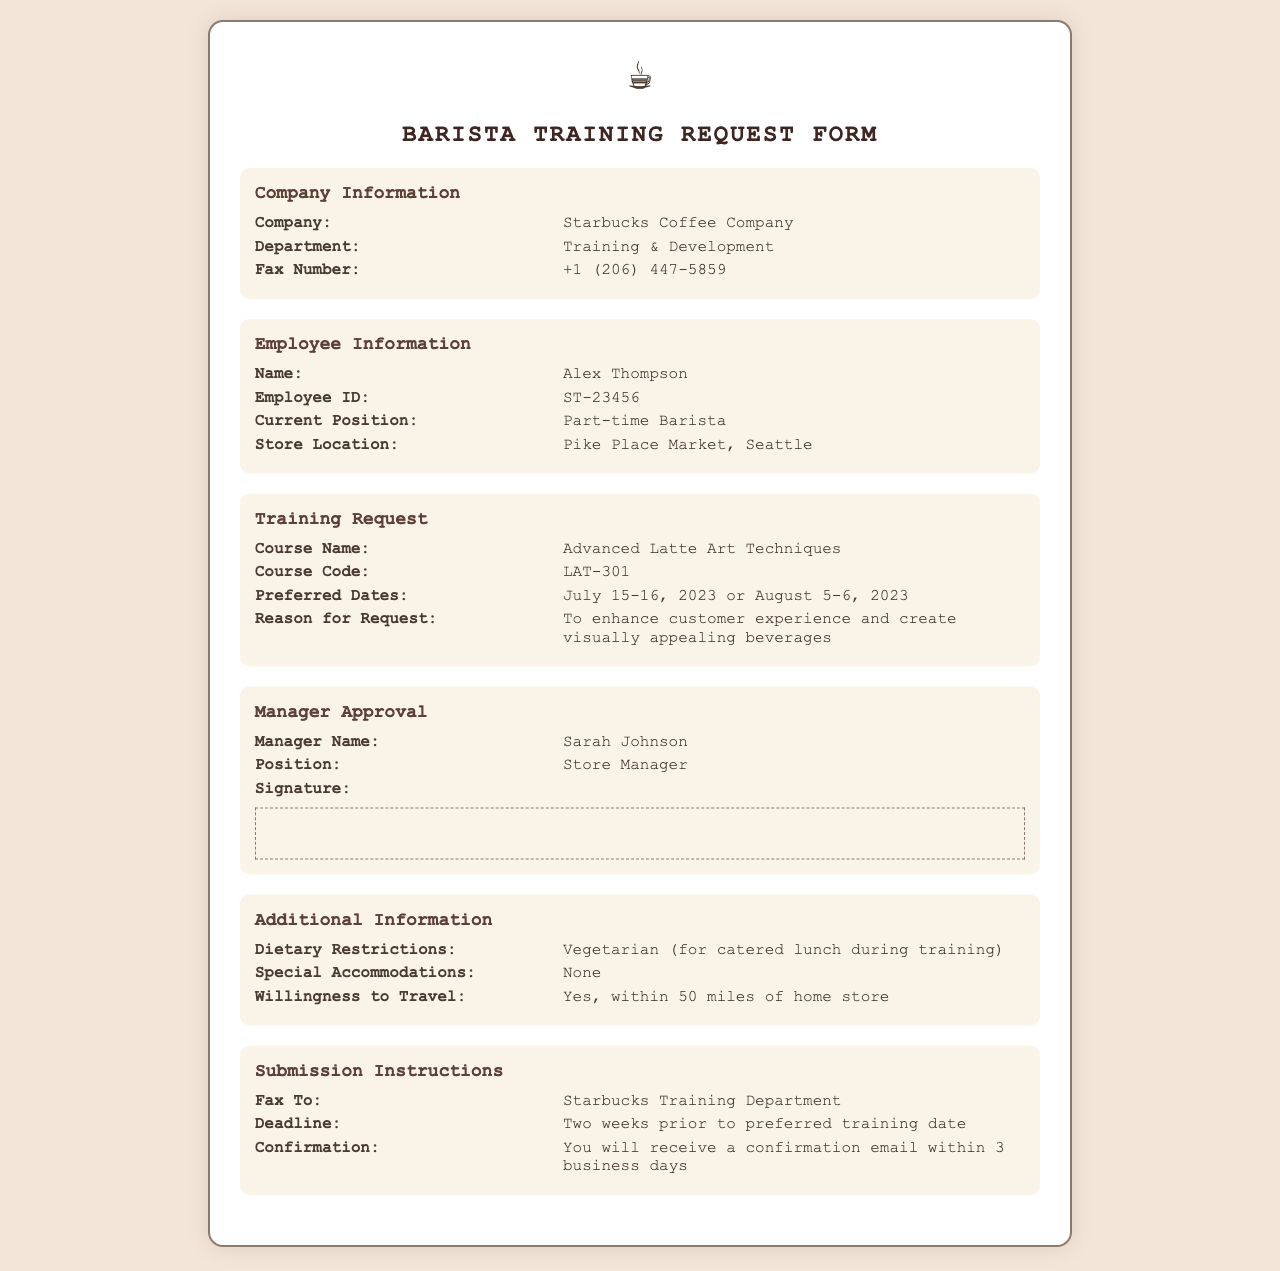What is the name of the course? The course name is specified in the training request section of the document, which is "Advanced Latte Art Techniques."
Answer: Advanced Latte Art Techniques What is the employee's current position? The employee's current position can be found in the employee information section, which states "Part-time Barista."
Answer: Part-time Barista What is the preferred training date? The preferred training dates are mentioned in the training request section, provided as "July 15-16, 2023 or August 5-6, 2023."
Answer: July 15-16, 2023 or August 5-6, 2023 What is the fax number for the company? The company's fax number is listed in the company information section as "+1 (206) 447-5859."
Answer: +1 (206) 447-5859 Who is the manager approving the training request? The manager's name can be found in the manager approval section, which states "Sarah Johnson."
Answer: Sarah Johnson What dietary restrictions does the employee have? The dietary restrictions are indicated in the additional information section, which states "Vegetarian."
Answer: Vegetarian When is the submission deadline for the request? The deadline for submission is outlined in the submission instructions, which states "Two weeks prior to preferred training date."
Answer: Two weeks prior to preferred training date What is the employee's store location? The employee's store location is mentioned in the employee information section as "Pike Place Market, Seattle."
Answer: Pike Place Market, Seattle What will the employee receive within 3 business days? It states in the submission instructions that the employee will receive a "confirmation email."
Answer: confirmation email 